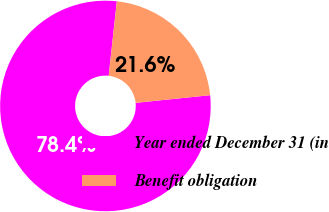Convert chart. <chart><loc_0><loc_0><loc_500><loc_500><pie_chart><fcel>Year ended December 31 (in<fcel>Benefit obligation<nl><fcel>78.36%<fcel>21.64%<nl></chart> 